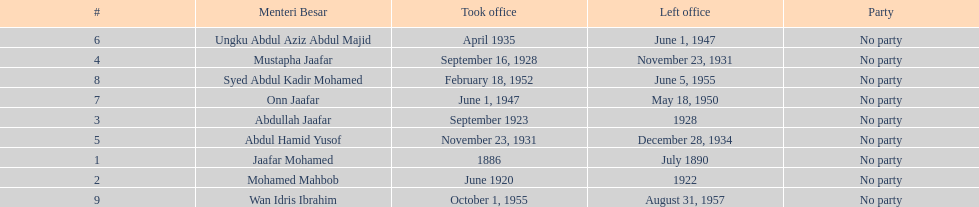What was the date the last person on the list left office? August 31, 1957. 